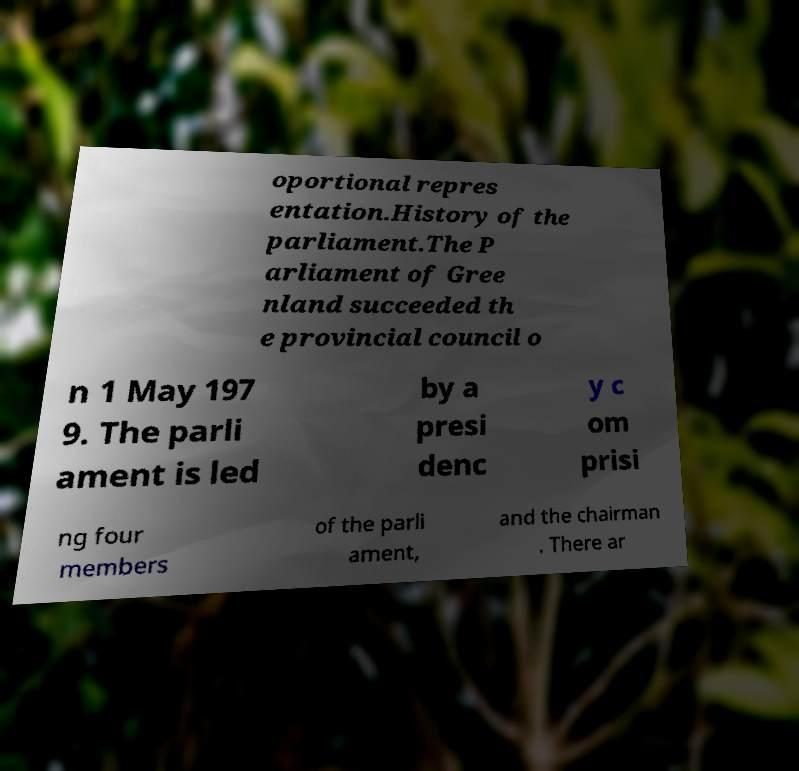What messages or text are displayed in this image? I need them in a readable, typed format. oportional repres entation.History of the parliament.The P arliament of Gree nland succeeded th e provincial council o n 1 May 197 9. The parli ament is led by a presi denc y c om prisi ng four members of the parli ament, and the chairman . There ar 